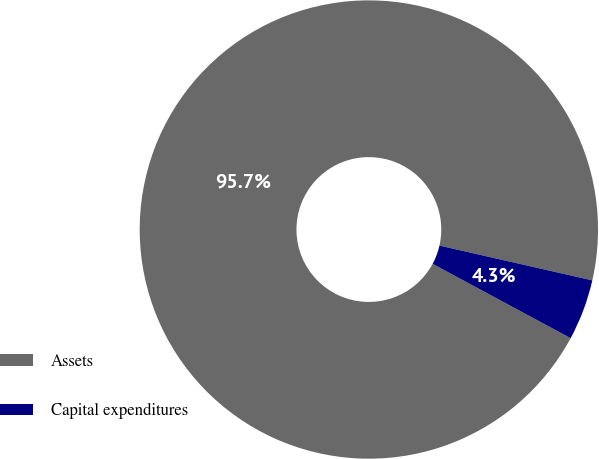<chart> <loc_0><loc_0><loc_500><loc_500><pie_chart><fcel>Assets<fcel>Capital expenditures<nl><fcel>95.7%<fcel>4.3%<nl></chart> 